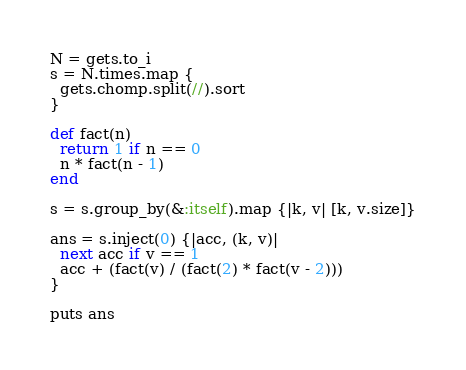<code> <loc_0><loc_0><loc_500><loc_500><_Ruby_>N = gets.to_i
s = N.times.map {
  gets.chomp.split(//).sort
}

def fact(n)
  return 1 if n == 0
  n * fact(n - 1)
end

s = s.group_by(&:itself).map {|k, v| [k, v.size]}

ans = s.inject(0) {|acc, (k, v)|
  next acc if v == 1
  acc + (fact(v) / (fact(2) * fact(v - 2)))
}

puts ans
</code> 